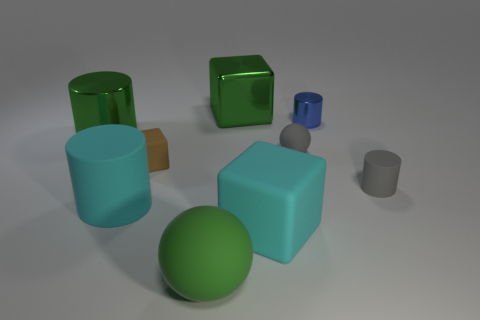What material is the object that is the same color as the big matte cylinder?
Give a very brief answer. Rubber. How many shiny things are big gray things or tiny brown blocks?
Provide a succinct answer. 0. What is the shape of the big green matte object?
Provide a short and direct response. Sphere. What number of big green cylinders are the same material as the small gray sphere?
Your answer should be compact. 0. The small sphere that is made of the same material as the brown object is what color?
Offer a very short reply. Gray. There is a matte cube that is on the left side of the green cube; does it have the same size as the large green matte object?
Give a very brief answer. No. The other tiny thing that is the same shape as the blue shiny thing is what color?
Provide a succinct answer. Gray. What shape is the green thing that is in front of the rubber sphere that is behind the large rubber block that is in front of the big matte cylinder?
Provide a short and direct response. Sphere. Is the shape of the green matte thing the same as the blue thing?
Give a very brief answer. No. There is a tiny matte object that is right of the shiny cylinder that is right of the large cyan cube; what is its shape?
Offer a very short reply. Cylinder. 